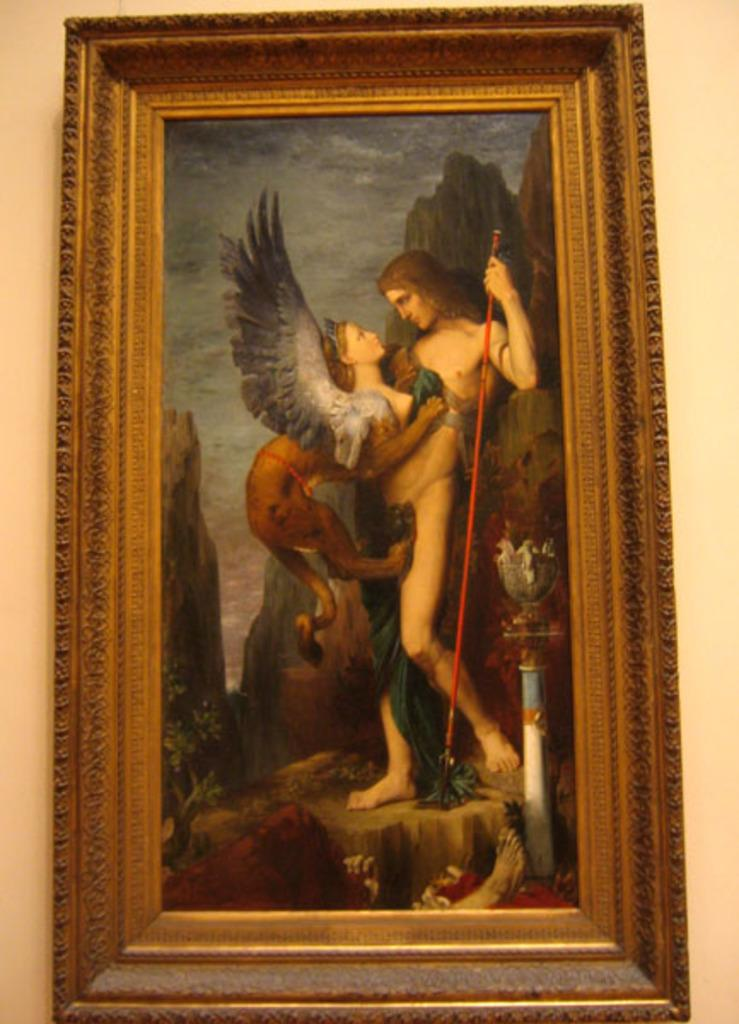What is hanging on the wall in the image? There is a photo frame on the wall in the image. What type of artwork is visible in the image? There is a painting in the image. What subjects are depicted in the painting? The painting contains people, hills, a sky, and plants. Who is the creator of the birthday scene in the painting? There is no birthday scene in the painting, and no creator is mentioned in the provided facts. How many kittens are playing in the grass in the painting? There are no kittens present in the painting; it contains people, hills, a sky, and plants. 